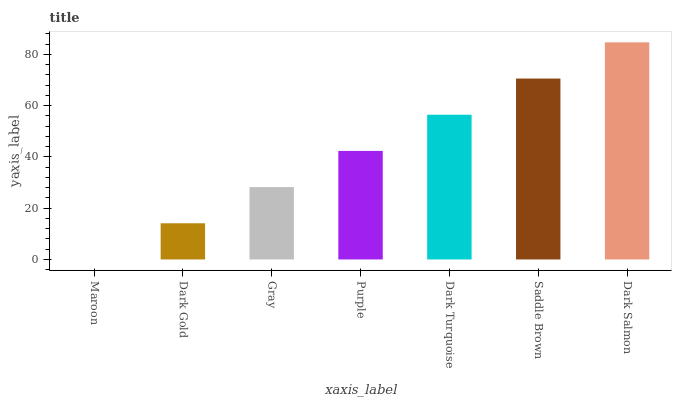Is Maroon the minimum?
Answer yes or no. Yes. Is Dark Salmon the maximum?
Answer yes or no. Yes. Is Dark Gold the minimum?
Answer yes or no. No. Is Dark Gold the maximum?
Answer yes or no. No. Is Dark Gold greater than Maroon?
Answer yes or no. Yes. Is Maroon less than Dark Gold?
Answer yes or no. Yes. Is Maroon greater than Dark Gold?
Answer yes or no. No. Is Dark Gold less than Maroon?
Answer yes or no. No. Is Purple the high median?
Answer yes or no. Yes. Is Purple the low median?
Answer yes or no. Yes. Is Saddle Brown the high median?
Answer yes or no. No. Is Dark Salmon the low median?
Answer yes or no. No. 